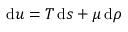Convert formula to latex. <formula><loc_0><loc_0><loc_500><loc_500>d u = T \, d s + \mu \, d \rho</formula> 